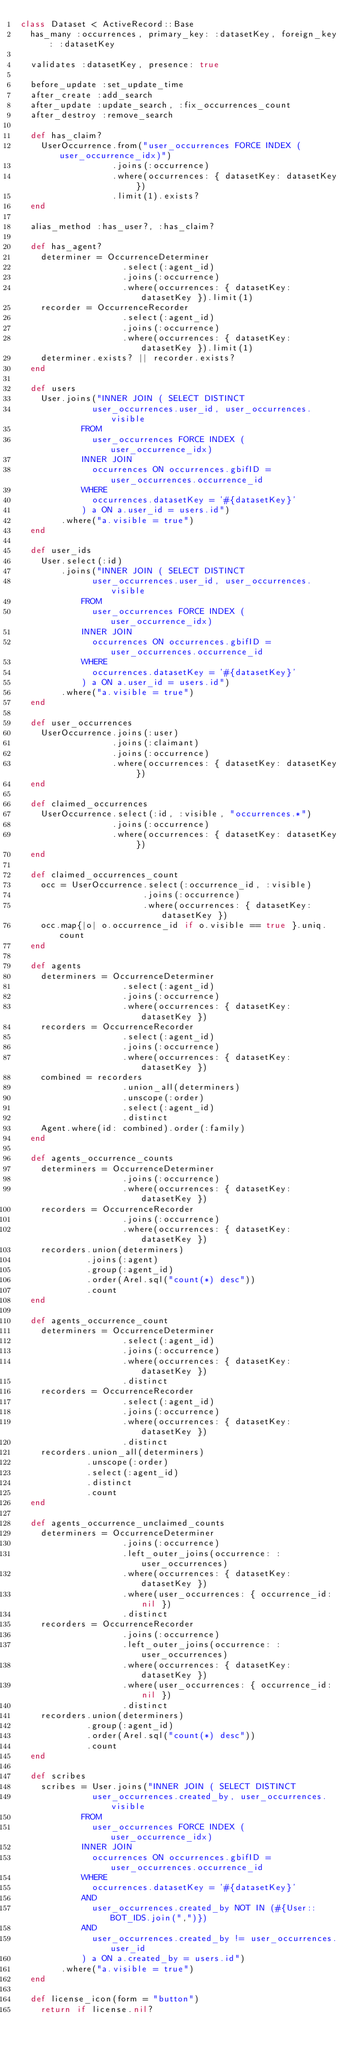<code> <loc_0><loc_0><loc_500><loc_500><_Ruby_>class Dataset < ActiveRecord::Base
  has_many :occurrences, primary_key: :datasetKey, foreign_key: :datasetKey

  validates :datasetKey, presence: true

  before_update :set_update_time
  after_create :add_search
  after_update :update_search, :fix_occurrences_count
  after_destroy :remove_search

  def has_claim?
    UserOccurrence.from("user_occurrences FORCE INDEX (user_occurrence_idx)")
                  .joins(:occurrence)
                  .where(occurrences: { datasetKey: datasetKey })
                  .limit(1).exists?
  end

  alias_method :has_user?, :has_claim?

  def has_agent?
    determiner = OccurrenceDeterminer
                    .select(:agent_id)
                    .joins(:occurrence)
                    .where(occurrences: { datasetKey: datasetKey }).limit(1)
    recorder = OccurrenceRecorder
                    .select(:agent_id)
                    .joins(:occurrence)
                    .where(occurrences: { datasetKey: datasetKey }).limit(1)
    determiner.exists? || recorder.exists?
  end

  def users
    User.joins("INNER JOIN ( SELECT DISTINCT
              user_occurrences.user_id, user_occurrences.visible
            FROM
              user_occurrences FORCE INDEX (user_occurrence_idx)
            INNER JOIN
              occurrences ON occurrences.gbifID = user_occurrences.occurrence_id
            WHERE
              occurrences.datasetKey = '#{datasetKey}'
            ) a ON a.user_id = users.id")
        .where("a.visible = true")
  end

  def user_ids
    User.select(:id)
        .joins("INNER JOIN ( SELECT DISTINCT
              user_occurrences.user_id, user_occurrences.visible
            FROM
              user_occurrences FORCE INDEX (user_occurrence_idx)
            INNER JOIN
              occurrences ON occurrences.gbifID = user_occurrences.occurrence_id
            WHERE
              occurrences.datasetKey = '#{datasetKey}'
            ) a ON a.user_id = users.id")
        .where("a.visible = true")
  end

  def user_occurrences
    UserOccurrence.joins(:user)
                  .joins(:claimant)
                  .joins(:occurrence)
                  .where(occurrences: { datasetKey: datasetKey })
  end

  def claimed_occurrences
    UserOccurrence.select(:id, :visible, "occurrences.*")
                  .joins(:occurrence)
                  .where(occurrences: { datasetKey: datasetKey })
  end

  def claimed_occurrences_count
    occ = UserOccurrence.select(:occurrence_id, :visible)
                        .joins(:occurrence)
                        .where(occurrences: { datasetKey: datasetKey })
    occ.map{|o| o.occurrence_id if o.visible == true }.uniq.count
  end

  def agents
    determiners = OccurrenceDeterminer
                    .select(:agent_id)
                    .joins(:occurrence)
                    .where(occurrences: { datasetKey: datasetKey })
    recorders = OccurrenceRecorder
                    .select(:agent_id)
                    .joins(:occurrence)
                    .where(occurrences: { datasetKey: datasetKey })
    combined = recorders
                    .union_all(determiners)
                    .unscope(:order)
                    .select(:agent_id)
                    .distinct
    Agent.where(id: combined).order(:family)
  end

  def agents_occurrence_counts
    determiners = OccurrenceDeterminer
                    .joins(:occurrence)
                    .where(occurrences: { datasetKey: datasetKey })
    recorders = OccurrenceRecorder
                    .joins(:occurrence)
                    .where(occurrences: { datasetKey: datasetKey })
    recorders.union(determiners)
             .joins(:agent)
             .group(:agent_id)
             .order(Arel.sql("count(*) desc"))
             .count
  end

  def agents_occurrence_count
    determiners = OccurrenceDeterminer
                    .select(:agent_id)
                    .joins(:occurrence)
                    .where(occurrences: { datasetKey: datasetKey })
                    .distinct
    recorders = OccurrenceRecorder
                    .select(:agent_id)
                    .joins(:occurrence)
                    .where(occurrences: { datasetKey: datasetKey })
                    .distinct
    recorders.union_all(determiners)
             .unscope(:order)
             .select(:agent_id)
             .distinct
             .count
  end

  def agents_occurrence_unclaimed_counts
    determiners = OccurrenceDeterminer
                    .joins(:occurrence)
                    .left_outer_joins(occurrence: :user_occurrences)
                    .where(occurrences: { datasetKey: datasetKey })
                    .where(user_occurrences: { occurrence_id: nil })
                    .distinct
    recorders = OccurrenceRecorder
                    .joins(:occurrence)
                    .left_outer_joins(occurrence: :user_occurrences)
                    .where(occurrences: { datasetKey: datasetKey })
                    .where(user_occurrences: { occurrence_id: nil })
                    .distinct
    recorders.union(determiners)
             .group(:agent_id)
             .order(Arel.sql("count(*) desc"))
             .count
  end

  def scribes
    scribes = User.joins("INNER JOIN ( SELECT DISTINCT
              user_occurrences.created_by, user_occurrences.visible
            FROM
              user_occurrences FORCE INDEX (user_occurrence_idx)
            INNER JOIN
              occurrences ON occurrences.gbifID = user_occurrences.occurrence_id
            WHERE
              occurrences.datasetKey = '#{datasetKey}'
            AND
              user_occurrences.created_by NOT IN (#{User::BOT_IDS.join(",")})
            AND
              user_occurrences.created_by != user_occurrences.user_id
            ) a ON a.created_by = users.id")
        .where("a.visible = true")
  end

  def license_icon(form = "button")
    return if license.nil?</code> 